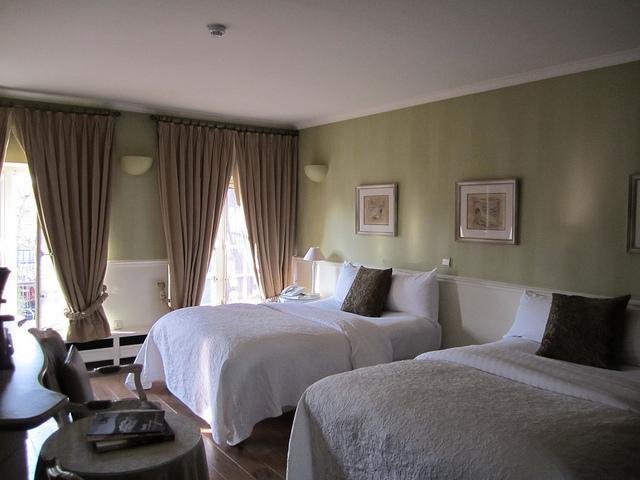How many people could sleep in this room?
Give a very brief answer. 4. How many beds are visible?
Give a very brief answer. 2. How many people are traveling?
Give a very brief answer. 0. 